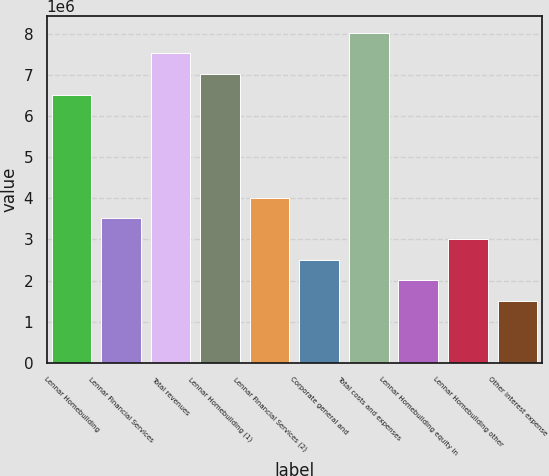Convert chart. <chart><loc_0><loc_0><loc_500><loc_500><bar_chart><fcel>Lennar Homebuilding<fcel>Lennar Financial Services<fcel>Total revenues<fcel>Lennar Homebuilding (1)<fcel>Lennar Financial Services (2)<fcel>Corporate general and<fcel>Total costs and expenses<fcel>Lennar Homebuilding equity in<fcel>Lennar Homebuilding other<fcel>Other interest expense<nl><fcel>6.5195e+06<fcel>3.5105e+06<fcel>7.5225e+06<fcel>7.021e+06<fcel>4.012e+06<fcel>2.5075e+06<fcel>8.024e+06<fcel>2.00601e+06<fcel>3.009e+06<fcel>1.50451e+06<nl></chart> 